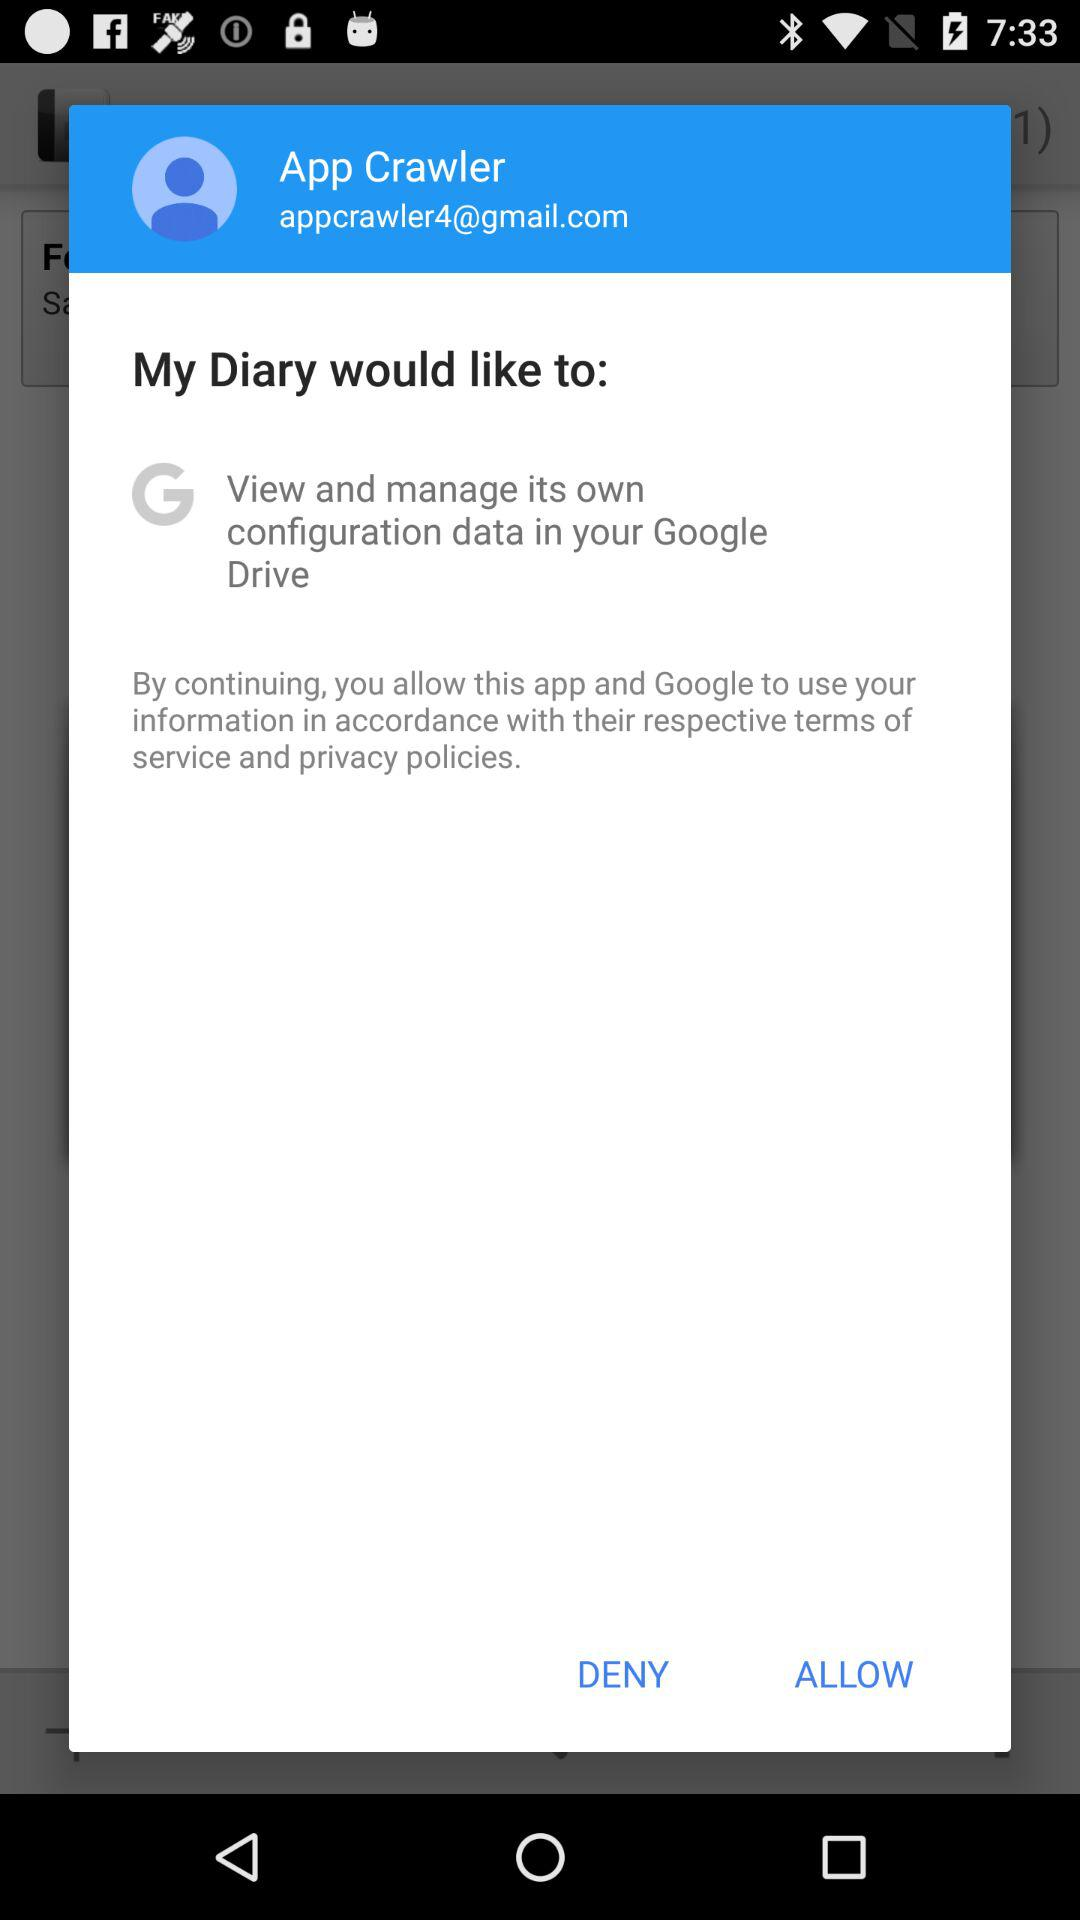What is the email address? The email address is appcrawler4@gmail.com. 